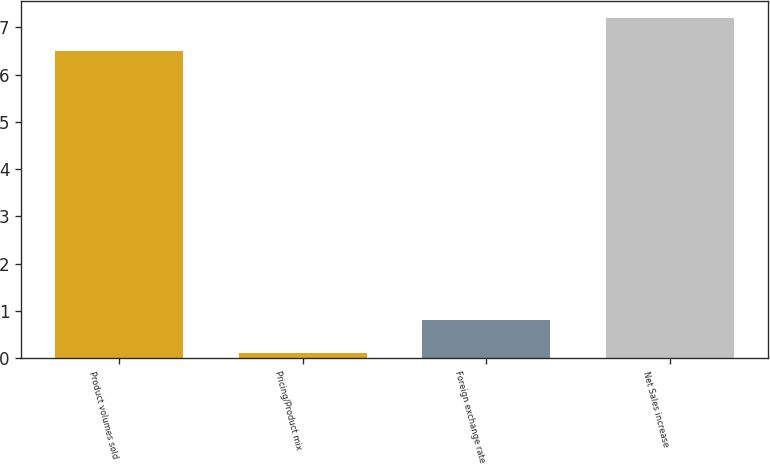Convert chart. <chart><loc_0><loc_0><loc_500><loc_500><bar_chart><fcel>Product volumes sold<fcel>Pricing/Product mix<fcel>Foreign exchange rate<fcel>Net Sales increase<nl><fcel>6.5<fcel>0.1<fcel>0.8<fcel>7.2<nl></chart> 